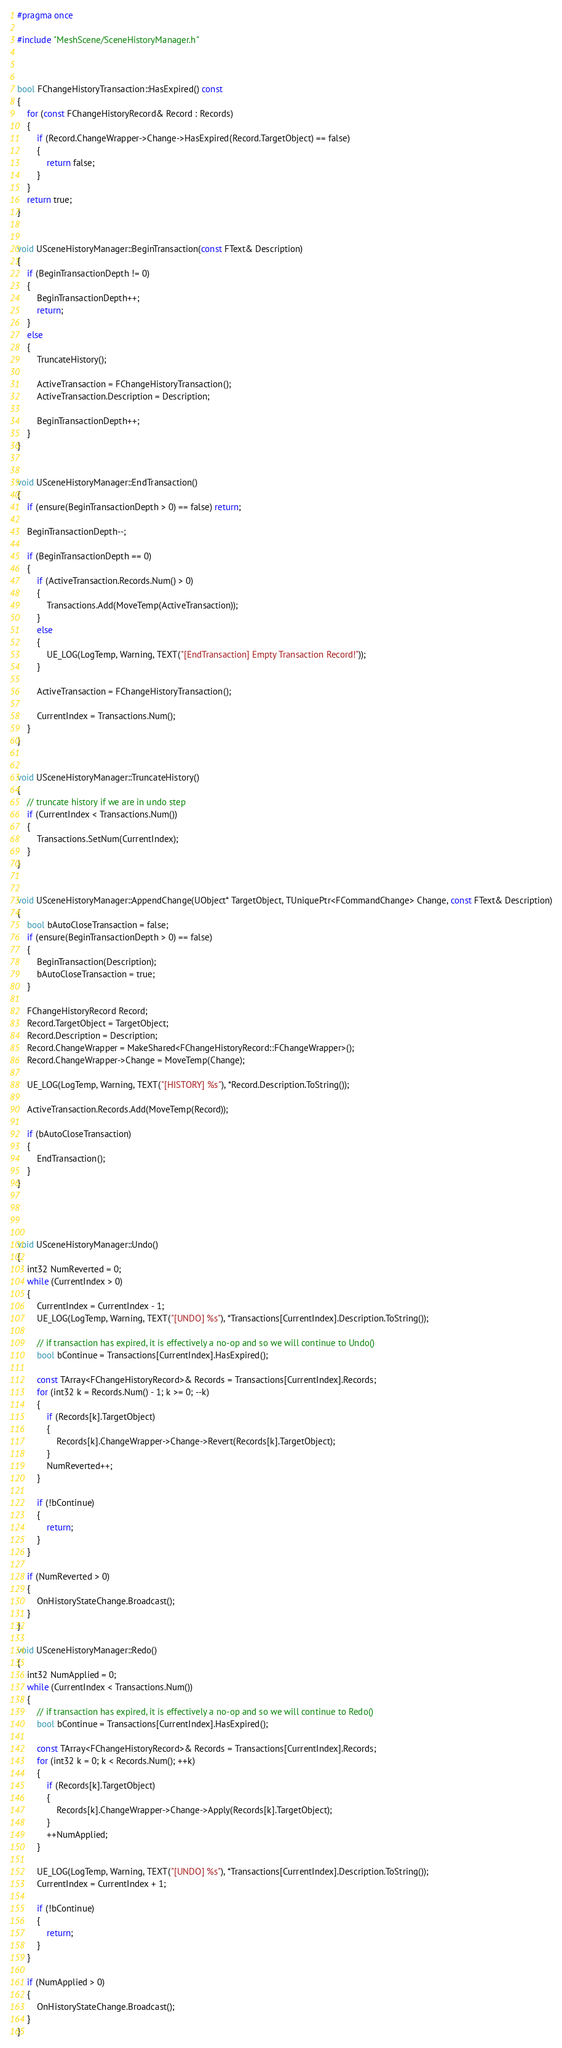Convert code to text. <code><loc_0><loc_0><loc_500><loc_500><_C++_>
#pragma once

#include "MeshScene/SceneHistoryManager.h"



bool FChangeHistoryTransaction::HasExpired() const
{
	for (const FChangeHistoryRecord& Record : Records)
	{
		if (Record.ChangeWrapper->Change->HasExpired(Record.TargetObject) == false)
		{
			return false;
		}
	}
	return true;
}


void USceneHistoryManager::BeginTransaction(const FText& Description)
{
	if (BeginTransactionDepth != 0)
	{
		BeginTransactionDepth++;
		return;
	}
	else
	{
		TruncateHistory();

		ActiveTransaction = FChangeHistoryTransaction();
		ActiveTransaction.Description = Description;

		BeginTransactionDepth++;
	}
}


void USceneHistoryManager::EndTransaction()
{
	if (ensure(BeginTransactionDepth > 0) == false) return;

	BeginTransactionDepth--;

	if (BeginTransactionDepth == 0)
	{
		if (ActiveTransaction.Records.Num() > 0)
		{
			Transactions.Add(MoveTemp(ActiveTransaction));
		}
		else
		{
			UE_LOG(LogTemp, Warning, TEXT("[EndTransaction] Empty Transaction Record!"));
		}

		ActiveTransaction = FChangeHistoryTransaction();

		CurrentIndex = Transactions.Num();
	}
}


void USceneHistoryManager::TruncateHistory()
{
	// truncate history if we are in undo step
	if (CurrentIndex < Transactions.Num())
	{
		Transactions.SetNum(CurrentIndex);
	}
}


void USceneHistoryManager::AppendChange(UObject* TargetObject, TUniquePtr<FCommandChange> Change, const FText& Description)
{
	bool bAutoCloseTransaction = false;
	if (ensure(BeginTransactionDepth > 0) == false)
	{
		BeginTransaction(Description);
		bAutoCloseTransaction = true;
	}

	FChangeHistoryRecord Record;
	Record.TargetObject = TargetObject;
	Record.Description = Description;
	Record.ChangeWrapper = MakeShared<FChangeHistoryRecord::FChangeWrapper>();
	Record.ChangeWrapper->Change = MoveTemp(Change);

	UE_LOG(LogTemp, Warning, TEXT("[HISTORY] %s"), *Record.Description.ToString());

	ActiveTransaction.Records.Add(MoveTemp(Record));

	if (bAutoCloseTransaction)
	{
		EndTransaction();
	}
}




void USceneHistoryManager::Undo()
{
	int32 NumReverted = 0;
	while (CurrentIndex > 0)
	{
		CurrentIndex = CurrentIndex - 1;
		UE_LOG(LogTemp, Warning, TEXT("[UNDO] %s"), *Transactions[CurrentIndex].Description.ToString());

		// if transaction has expired, it is effectively a no-op and so we will continue to Undo()
		bool bContinue = Transactions[CurrentIndex].HasExpired();

		const TArray<FChangeHistoryRecord>& Records = Transactions[CurrentIndex].Records;
		for (int32 k = Records.Num() - 1; k >= 0; --k)
		{
			if (Records[k].TargetObject)
			{
				Records[k].ChangeWrapper->Change->Revert(Records[k].TargetObject);
			}
			NumReverted++;
		}

		if (!bContinue)
		{
			return;
		}
	}

	if (NumReverted > 0)
	{
		OnHistoryStateChange.Broadcast();
	}
}

void USceneHistoryManager::Redo()
{
	int32 NumApplied = 0;
	while (CurrentIndex < Transactions.Num())
	{
		// if transaction has expired, it is effectively a no-op and so we will continue to Redo()
		bool bContinue = Transactions[CurrentIndex].HasExpired();

		const TArray<FChangeHistoryRecord>& Records = Transactions[CurrentIndex].Records;
		for (int32 k = 0; k < Records.Num(); ++k)
		{
			if (Records[k].TargetObject)
			{
				Records[k].ChangeWrapper->Change->Apply(Records[k].TargetObject);
			}
			++NumApplied;
		}

		UE_LOG(LogTemp, Warning, TEXT("[UNDO] %s"), *Transactions[CurrentIndex].Description.ToString());
		CurrentIndex = CurrentIndex + 1;

		if (!bContinue)
		{
			return;
		}
	}

	if (NumApplied > 0)
	{
		OnHistoryStateChange.Broadcast();
	}
}
</code> 